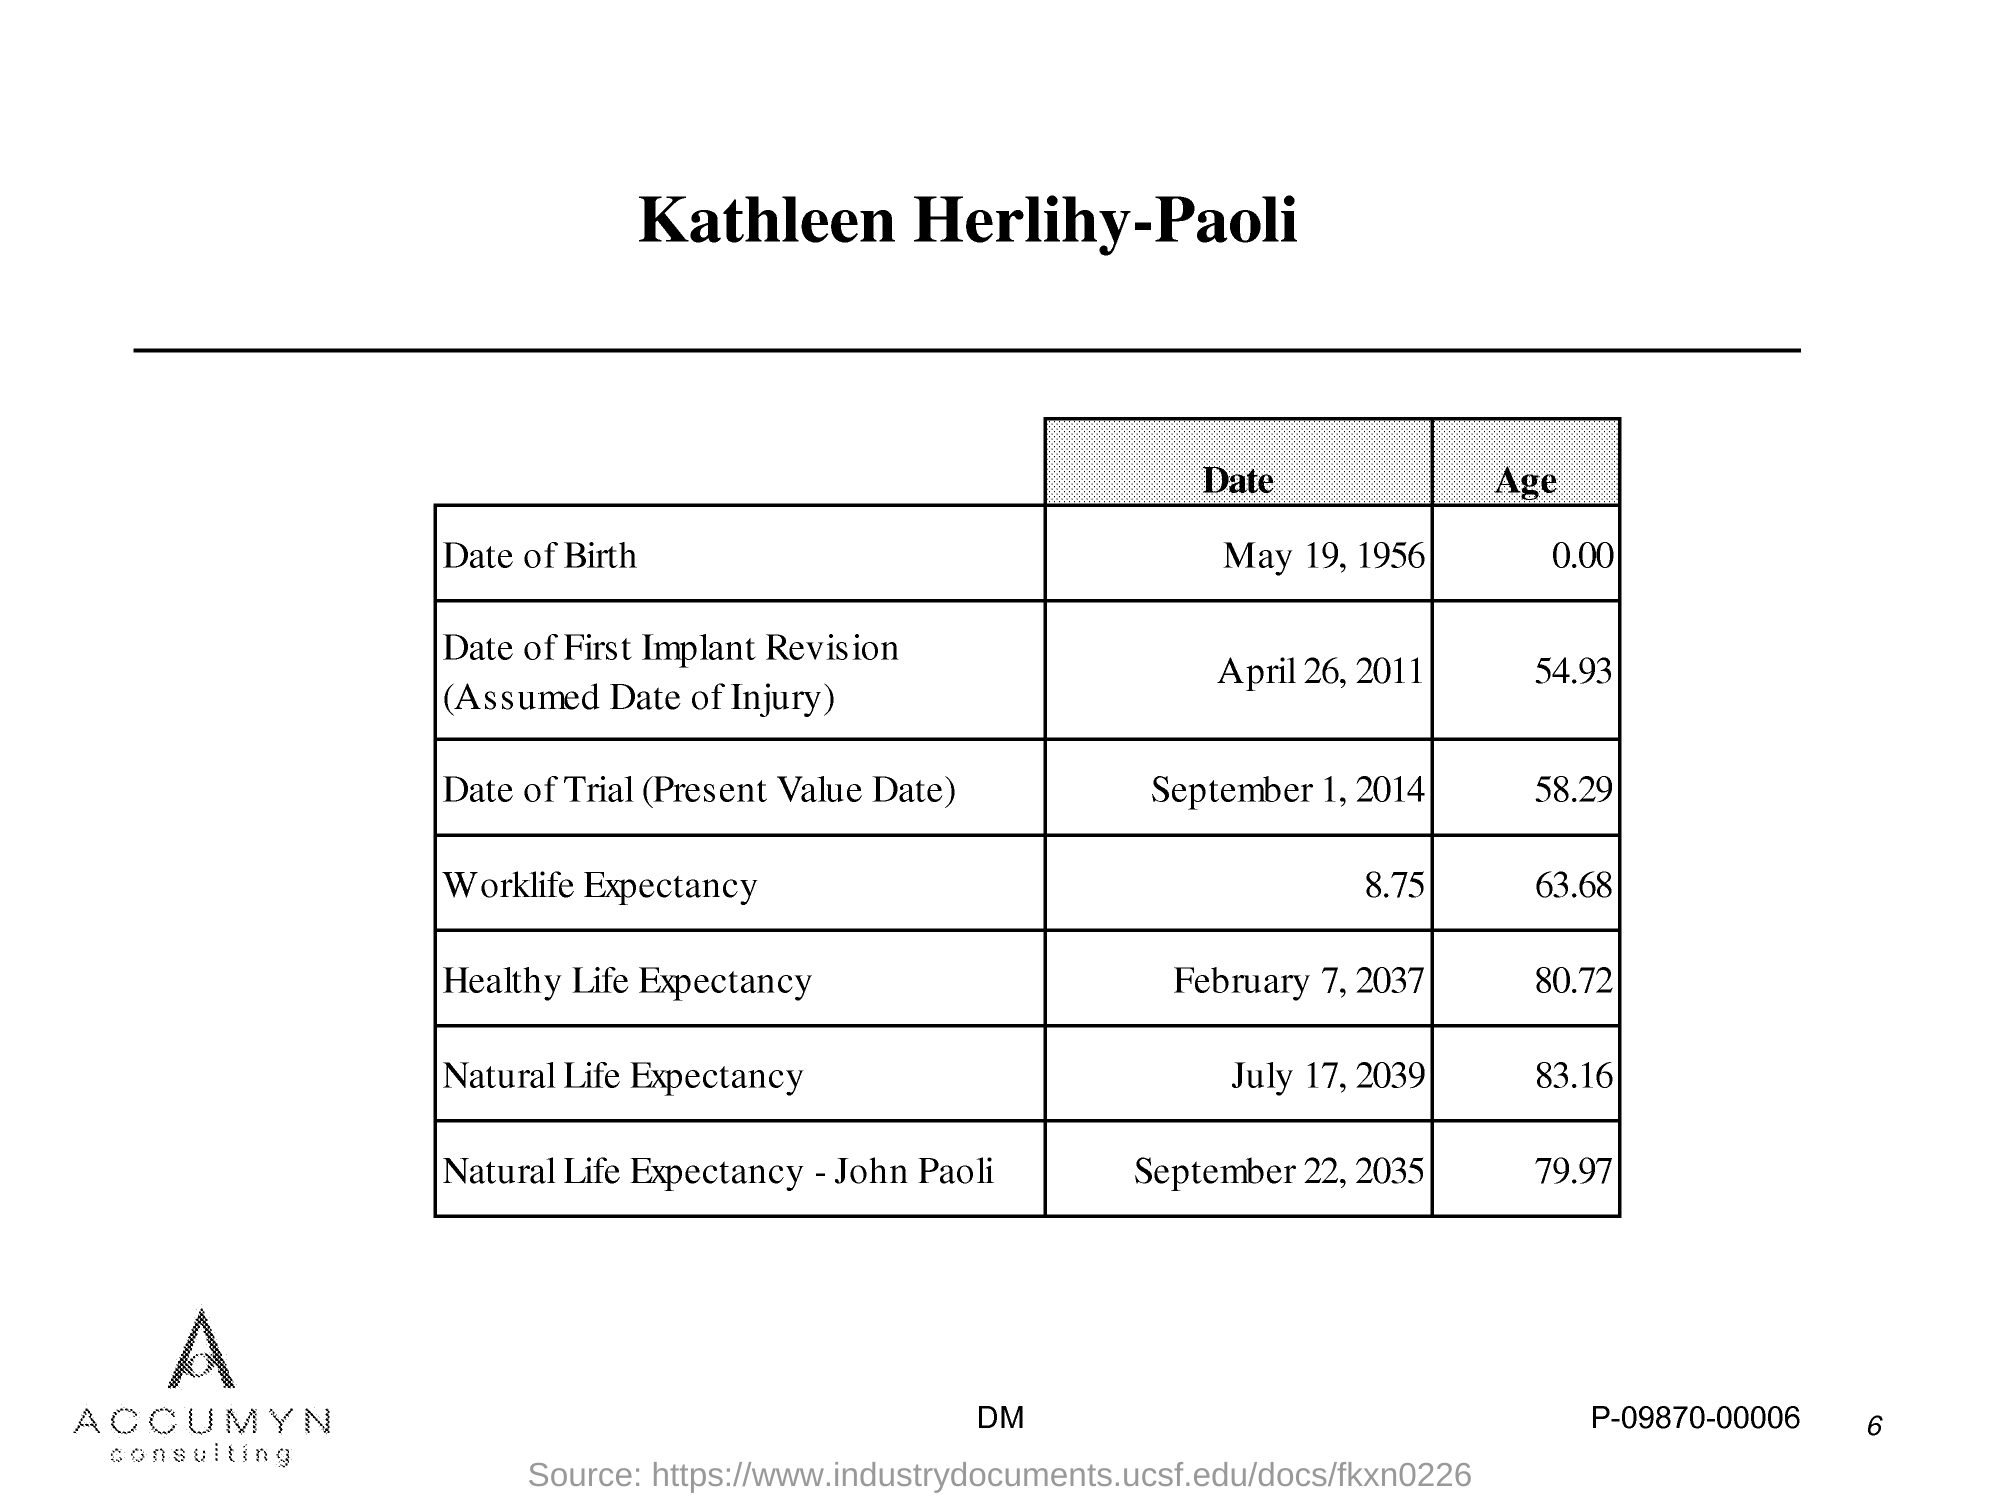What is the title of the document?
Make the answer very short. Kathleen Herlihy-Paoli. 